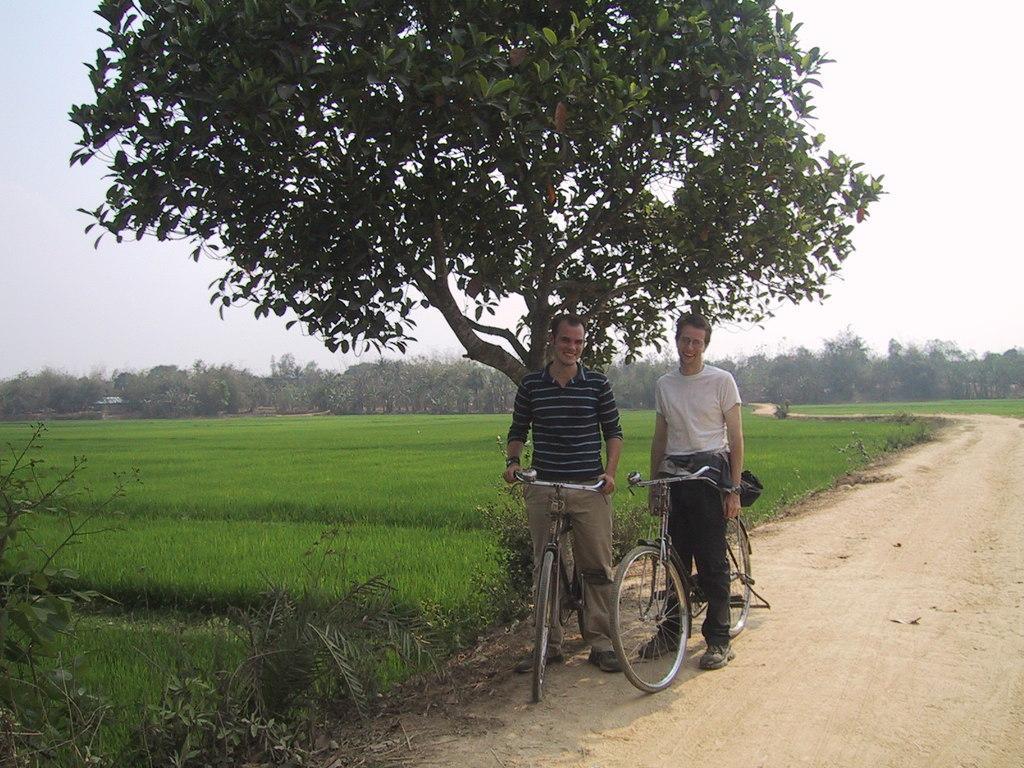Describe this image in one or two sentences. two mans standing on a bicycle under the tree. here the paddy field. Background we can see a group of trees, here it's a road and the sky is open there is no clouds. 